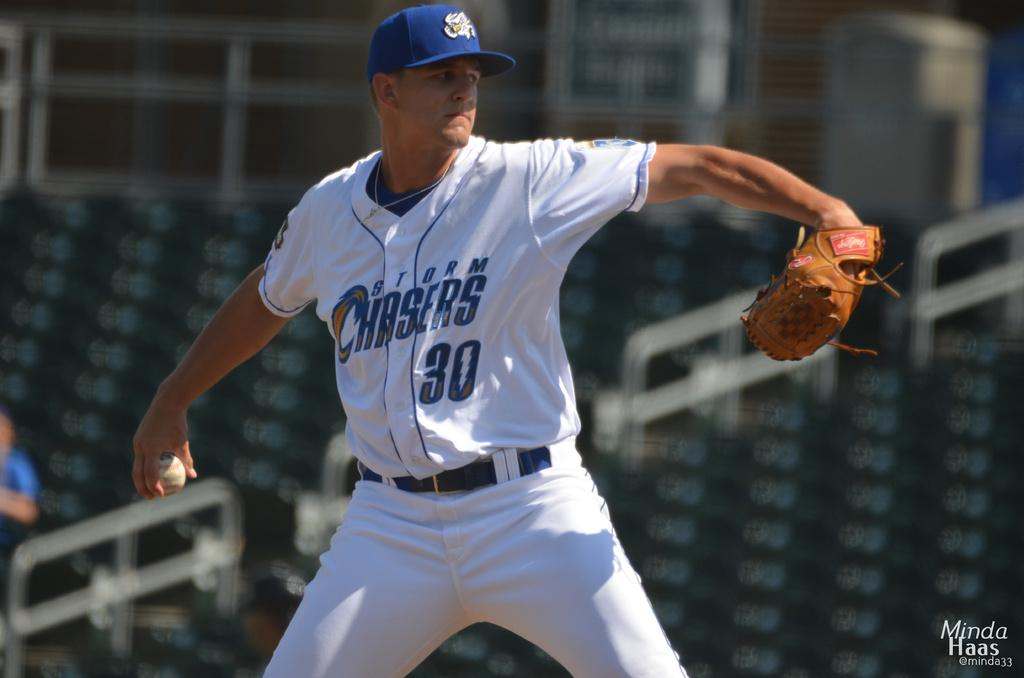What is the man in the image doing? The man is playing baseball in the image. What type of clothing is the man wearing? The man is wearing a white dress in the image. What protective gear is the man wearing while playing baseball? The man is wearing gloves in the image. How many horses are present in the image? There are no horses present in the image. What is the man's opinion on the rod in the image? There is no rod present in the image, and therefore no opinion can be determined. 